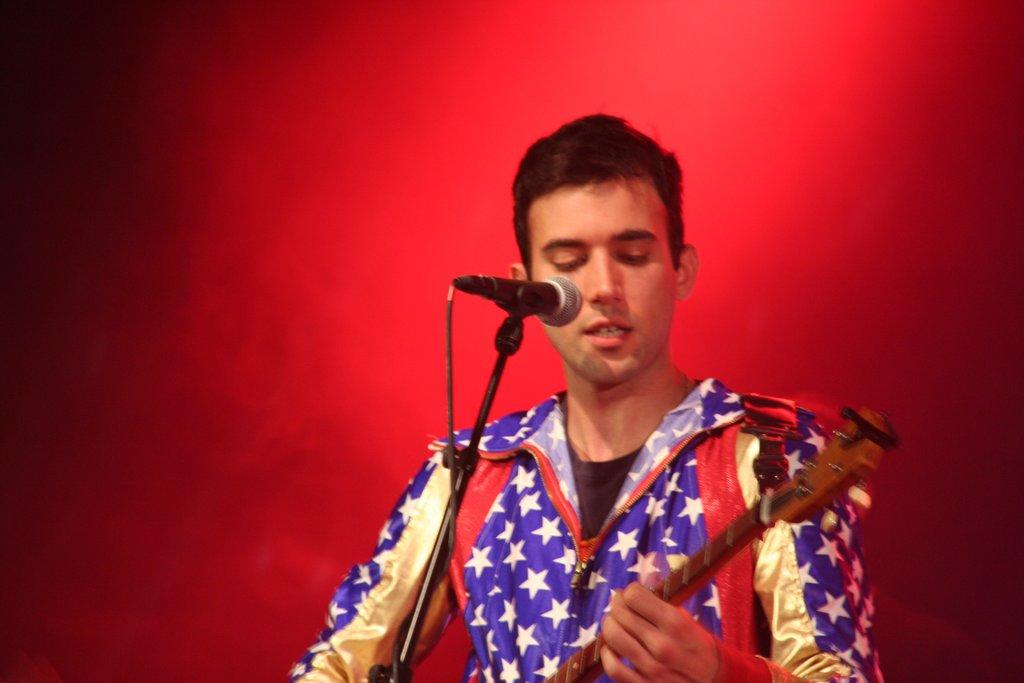What is the main subject of the image? The main subject of the image is a man. What is the man doing in the image? The man is standing, playing the guitar, and singing. What object is in front of the man? There is a microphone in front of the man. What color is the backdrop in the image? The backdrop is red in color. What type of tree can be seen in the background of the image? There is no tree visible in the background of the image; the backdrop is red in color. 